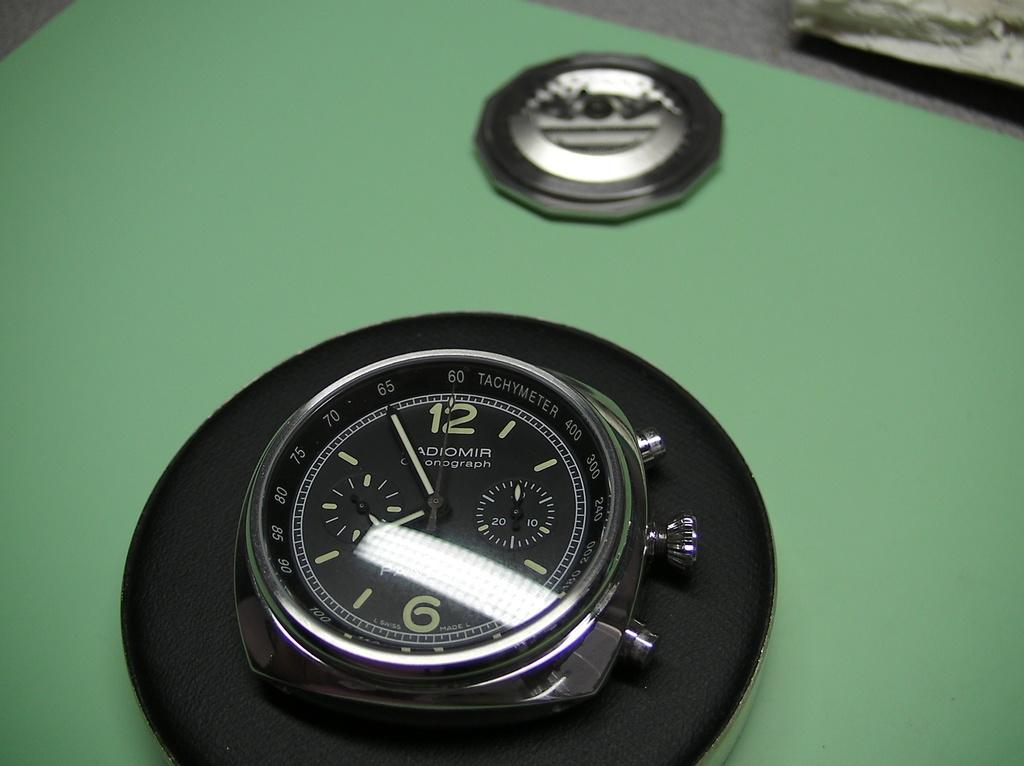<image>
Share a concise interpretation of the image provided. A pocket watch is sitting on display showing 7:55. 